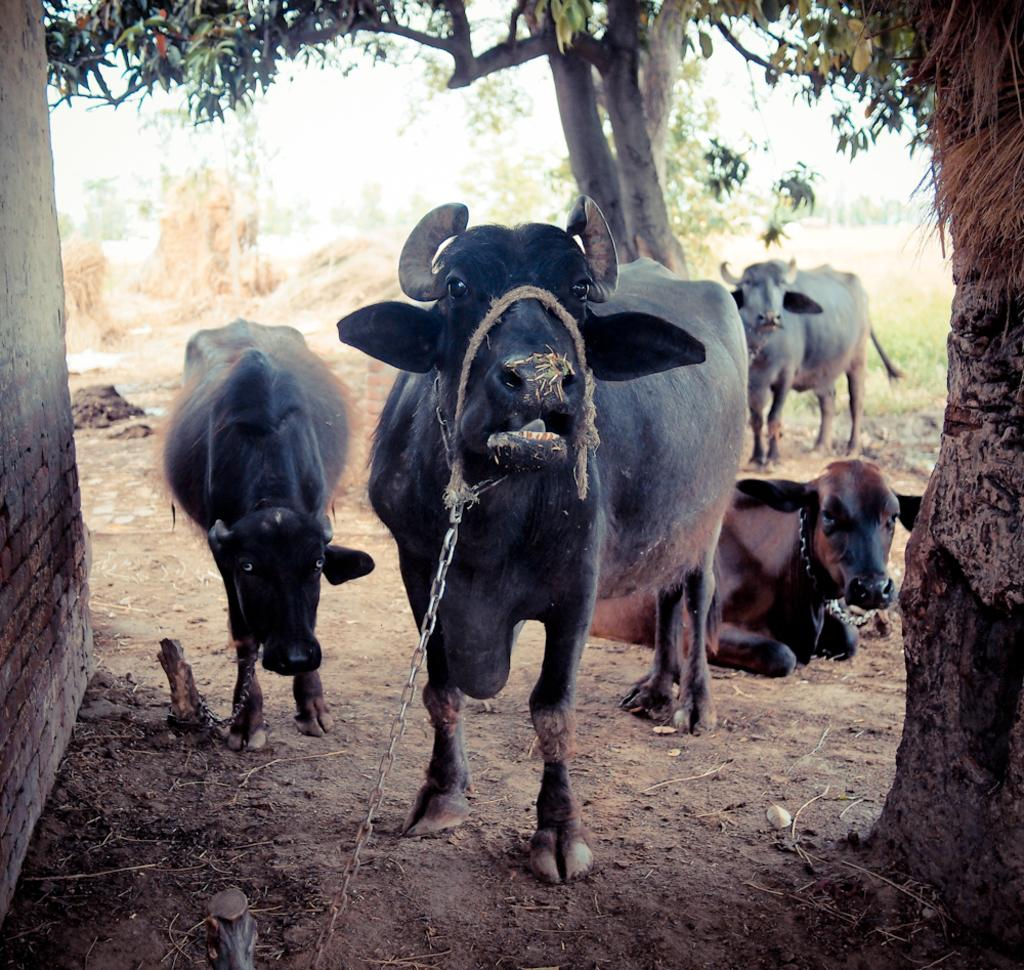What animals are present in the image? There are buffaloes in the image. How are the buffaloes restrained in the image? The buffaloes are tied with a chain. What type of structure can be seen in the image? There is a wall in the image. What part of a tree is visible in the image? A bark of a tree is visible in the image. What type of vegetation is present in the image? Dried grass is present in the image. What can be seen in the background of the image? There is a tree visible in the background of the image. What language are the buffaloes speaking in the image? Buffaloes do not speak any language, so this question cannot be answered. 